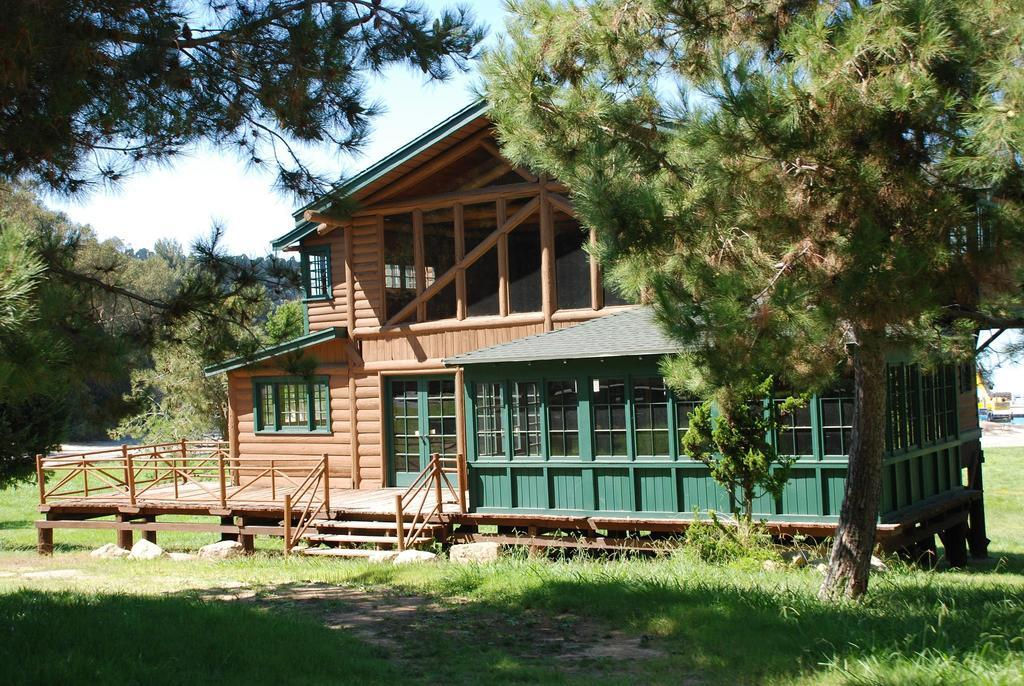What type of structure is visible in the image? There is a house in the image. What features can be seen on the house? The house has windows and a door. What architectural element is present in the image? There is a staircase in the image. What items are related to cooking or outdoor activities? There are grills in the image. What type of vegetation is present in the image? There are plants, trees, and grass in the image. What part of the natural environment is visible in the image? The sky is visible in the image. What type of animal is playing with the daughter in the image? There is no daughter or animal present in the image. 